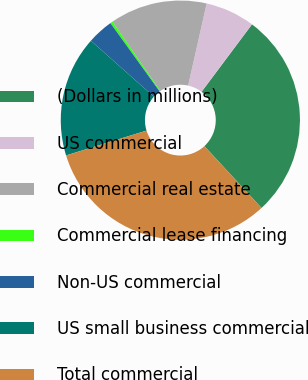<chart> <loc_0><loc_0><loc_500><loc_500><pie_chart><fcel>(Dollars in millions)<fcel>US commercial<fcel>Commercial real estate<fcel>Commercial lease financing<fcel>Non-US commercial<fcel>US small business commercial<fcel>Total commercial<nl><fcel>27.91%<fcel>6.69%<fcel>13.14%<fcel>0.33%<fcel>3.51%<fcel>16.32%<fcel>32.1%<nl></chart> 